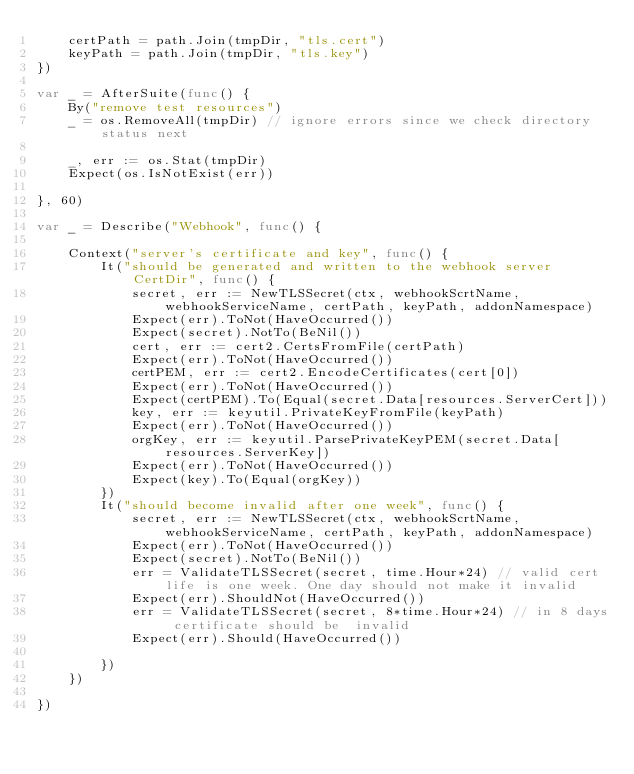Convert code to text. <code><loc_0><loc_0><loc_500><loc_500><_Go_>	certPath = path.Join(tmpDir, "tls.cert")
	keyPath = path.Join(tmpDir, "tls.key")
})

var _ = AfterSuite(func() {
	By("remove test resources")
	_ = os.RemoveAll(tmpDir) // ignore errors since we check directory status next

	_, err := os.Stat(tmpDir)
	Expect(os.IsNotExist(err))

}, 60)

var _ = Describe("Webhook", func() {

	Context("server's certificate and key", func() {
		It("should be generated and written to the webhook server CertDir", func() {
			secret, err := NewTLSSecret(ctx, webhookScrtName, webhookServiceName, certPath, keyPath, addonNamespace)
			Expect(err).ToNot(HaveOccurred())
			Expect(secret).NotTo(BeNil())
			cert, err := cert2.CertsFromFile(certPath)
			Expect(err).ToNot(HaveOccurred())
			certPEM, err := cert2.EncodeCertificates(cert[0])
			Expect(err).ToNot(HaveOccurred())
			Expect(certPEM).To(Equal(secret.Data[resources.ServerCert]))
			key, err := keyutil.PrivateKeyFromFile(keyPath)
			Expect(err).ToNot(HaveOccurred())
			orgKey, err := keyutil.ParsePrivateKeyPEM(secret.Data[resources.ServerKey])
			Expect(err).ToNot(HaveOccurred())
			Expect(key).To(Equal(orgKey))
		})
		It("should become invalid after one week", func() {
			secret, err := NewTLSSecret(ctx, webhookScrtName, webhookServiceName, certPath, keyPath, addonNamespace)
			Expect(err).ToNot(HaveOccurred())
			Expect(secret).NotTo(BeNil())
			err = ValidateTLSSecret(secret, time.Hour*24) // valid cert life is one week. One day should not make it invalid
			Expect(err).ShouldNot(HaveOccurred())
			err = ValidateTLSSecret(secret, 8*time.Hour*24) // in 8 days certificate should be  invalid
			Expect(err).Should(HaveOccurred())

		})
	})

})
</code> 